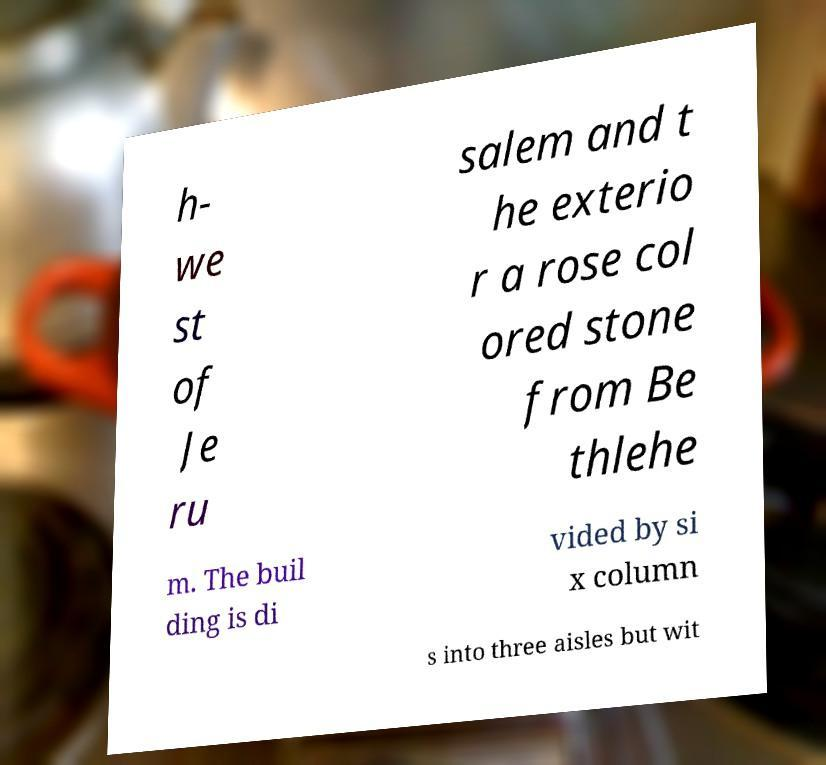Please identify and transcribe the text found in this image. h- we st of Je ru salem and t he exterio r a rose col ored stone from Be thlehe m. The buil ding is di vided by si x column s into three aisles but wit 